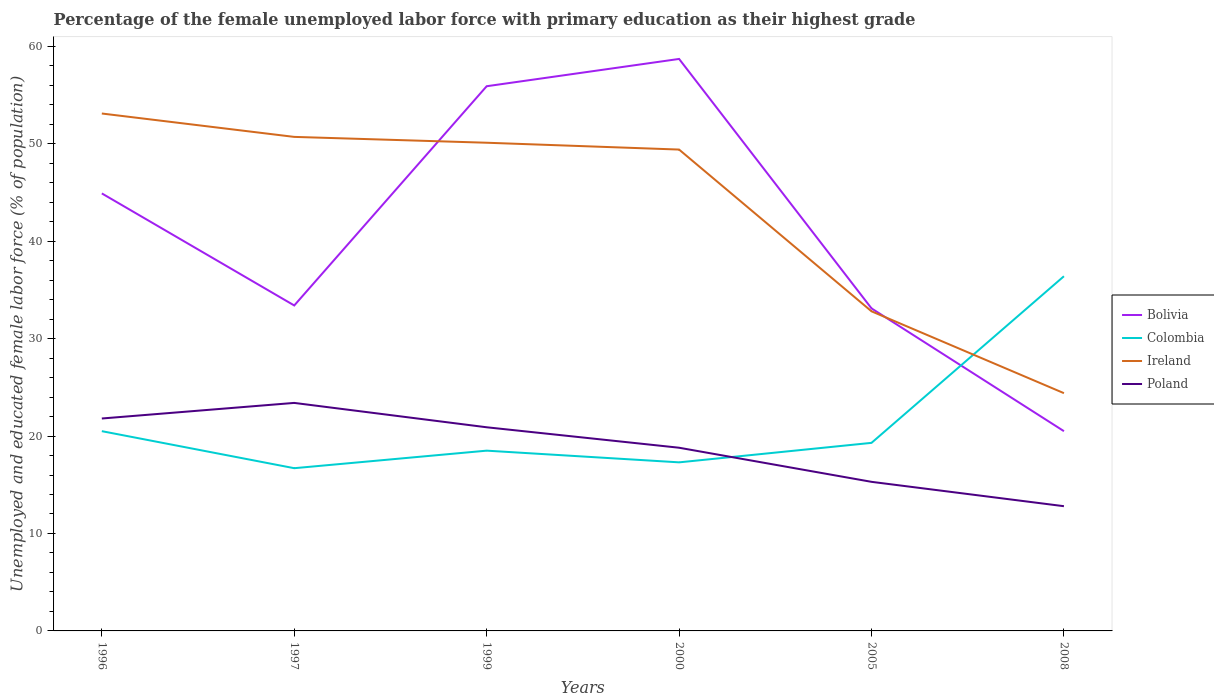Does the line corresponding to Ireland intersect with the line corresponding to Poland?
Your answer should be compact. No. Is the number of lines equal to the number of legend labels?
Provide a short and direct response. Yes. Across all years, what is the maximum percentage of the unemployed female labor force with primary education in Ireland?
Provide a succinct answer. 24.4. In which year was the percentage of the unemployed female labor force with primary education in Poland maximum?
Your answer should be very brief. 2008. What is the total percentage of the unemployed female labor force with primary education in Poland in the graph?
Keep it short and to the point. 6.5. What is the difference between the highest and the second highest percentage of the unemployed female labor force with primary education in Ireland?
Give a very brief answer. 28.7. What is the difference between the highest and the lowest percentage of the unemployed female labor force with primary education in Ireland?
Provide a short and direct response. 4. Is the percentage of the unemployed female labor force with primary education in Colombia strictly greater than the percentage of the unemployed female labor force with primary education in Bolivia over the years?
Your answer should be compact. No. How many years are there in the graph?
Your answer should be compact. 6. Are the values on the major ticks of Y-axis written in scientific E-notation?
Provide a short and direct response. No. Does the graph contain grids?
Offer a terse response. No. How many legend labels are there?
Provide a short and direct response. 4. How are the legend labels stacked?
Offer a terse response. Vertical. What is the title of the graph?
Provide a succinct answer. Percentage of the female unemployed labor force with primary education as their highest grade. Does "Lesotho" appear as one of the legend labels in the graph?
Provide a succinct answer. No. What is the label or title of the Y-axis?
Offer a very short reply. Unemployed and educated female labor force (% of population). What is the Unemployed and educated female labor force (% of population) of Bolivia in 1996?
Offer a terse response. 44.9. What is the Unemployed and educated female labor force (% of population) of Ireland in 1996?
Keep it short and to the point. 53.1. What is the Unemployed and educated female labor force (% of population) of Poland in 1996?
Your response must be concise. 21.8. What is the Unemployed and educated female labor force (% of population) in Bolivia in 1997?
Provide a short and direct response. 33.4. What is the Unemployed and educated female labor force (% of population) in Colombia in 1997?
Provide a succinct answer. 16.7. What is the Unemployed and educated female labor force (% of population) of Ireland in 1997?
Give a very brief answer. 50.7. What is the Unemployed and educated female labor force (% of population) of Poland in 1997?
Give a very brief answer. 23.4. What is the Unemployed and educated female labor force (% of population) in Bolivia in 1999?
Provide a short and direct response. 55.9. What is the Unemployed and educated female labor force (% of population) in Colombia in 1999?
Keep it short and to the point. 18.5. What is the Unemployed and educated female labor force (% of population) in Ireland in 1999?
Ensure brevity in your answer.  50.1. What is the Unemployed and educated female labor force (% of population) in Poland in 1999?
Provide a short and direct response. 20.9. What is the Unemployed and educated female labor force (% of population) in Bolivia in 2000?
Provide a succinct answer. 58.7. What is the Unemployed and educated female labor force (% of population) in Colombia in 2000?
Your answer should be compact. 17.3. What is the Unemployed and educated female labor force (% of population) in Ireland in 2000?
Offer a terse response. 49.4. What is the Unemployed and educated female labor force (% of population) of Poland in 2000?
Your response must be concise. 18.8. What is the Unemployed and educated female labor force (% of population) of Bolivia in 2005?
Offer a very short reply. 33.1. What is the Unemployed and educated female labor force (% of population) of Colombia in 2005?
Provide a short and direct response. 19.3. What is the Unemployed and educated female labor force (% of population) of Ireland in 2005?
Your answer should be very brief. 32.8. What is the Unemployed and educated female labor force (% of population) of Poland in 2005?
Your answer should be compact. 15.3. What is the Unemployed and educated female labor force (% of population) in Bolivia in 2008?
Offer a very short reply. 20.5. What is the Unemployed and educated female labor force (% of population) in Colombia in 2008?
Your answer should be very brief. 36.4. What is the Unemployed and educated female labor force (% of population) of Ireland in 2008?
Give a very brief answer. 24.4. What is the Unemployed and educated female labor force (% of population) in Poland in 2008?
Your answer should be compact. 12.8. Across all years, what is the maximum Unemployed and educated female labor force (% of population) in Bolivia?
Ensure brevity in your answer.  58.7. Across all years, what is the maximum Unemployed and educated female labor force (% of population) of Colombia?
Offer a very short reply. 36.4. Across all years, what is the maximum Unemployed and educated female labor force (% of population) in Ireland?
Make the answer very short. 53.1. Across all years, what is the maximum Unemployed and educated female labor force (% of population) of Poland?
Your answer should be very brief. 23.4. Across all years, what is the minimum Unemployed and educated female labor force (% of population) of Bolivia?
Offer a terse response. 20.5. Across all years, what is the minimum Unemployed and educated female labor force (% of population) in Colombia?
Provide a short and direct response. 16.7. Across all years, what is the minimum Unemployed and educated female labor force (% of population) of Ireland?
Your response must be concise. 24.4. Across all years, what is the minimum Unemployed and educated female labor force (% of population) in Poland?
Your answer should be very brief. 12.8. What is the total Unemployed and educated female labor force (% of population) in Bolivia in the graph?
Make the answer very short. 246.5. What is the total Unemployed and educated female labor force (% of population) in Colombia in the graph?
Ensure brevity in your answer.  128.7. What is the total Unemployed and educated female labor force (% of population) of Ireland in the graph?
Your answer should be very brief. 260.5. What is the total Unemployed and educated female labor force (% of population) in Poland in the graph?
Offer a very short reply. 113. What is the difference between the Unemployed and educated female labor force (% of population) of Colombia in 1996 and that in 1997?
Provide a short and direct response. 3.8. What is the difference between the Unemployed and educated female labor force (% of population) of Colombia in 1996 and that in 1999?
Provide a short and direct response. 2. What is the difference between the Unemployed and educated female labor force (% of population) of Ireland in 1996 and that in 1999?
Give a very brief answer. 3. What is the difference between the Unemployed and educated female labor force (% of population) of Poland in 1996 and that in 2000?
Make the answer very short. 3. What is the difference between the Unemployed and educated female labor force (% of population) of Bolivia in 1996 and that in 2005?
Provide a short and direct response. 11.8. What is the difference between the Unemployed and educated female labor force (% of population) of Ireland in 1996 and that in 2005?
Make the answer very short. 20.3. What is the difference between the Unemployed and educated female labor force (% of population) of Bolivia in 1996 and that in 2008?
Make the answer very short. 24.4. What is the difference between the Unemployed and educated female labor force (% of population) of Colombia in 1996 and that in 2008?
Provide a short and direct response. -15.9. What is the difference between the Unemployed and educated female labor force (% of population) of Ireland in 1996 and that in 2008?
Keep it short and to the point. 28.7. What is the difference between the Unemployed and educated female labor force (% of population) of Poland in 1996 and that in 2008?
Your response must be concise. 9. What is the difference between the Unemployed and educated female labor force (% of population) in Bolivia in 1997 and that in 1999?
Offer a very short reply. -22.5. What is the difference between the Unemployed and educated female labor force (% of population) in Poland in 1997 and that in 1999?
Your response must be concise. 2.5. What is the difference between the Unemployed and educated female labor force (% of population) of Bolivia in 1997 and that in 2000?
Offer a very short reply. -25.3. What is the difference between the Unemployed and educated female labor force (% of population) in Ireland in 1997 and that in 2000?
Offer a terse response. 1.3. What is the difference between the Unemployed and educated female labor force (% of population) of Bolivia in 1997 and that in 2005?
Keep it short and to the point. 0.3. What is the difference between the Unemployed and educated female labor force (% of population) in Colombia in 1997 and that in 2005?
Make the answer very short. -2.6. What is the difference between the Unemployed and educated female labor force (% of population) of Poland in 1997 and that in 2005?
Your answer should be very brief. 8.1. What is the difference between the Unemployed and educated female labor force (% of population) in Bolivia in 1997 and that in 2008?
Offer a very short reply. 12.9. What is the difference between the Unemployed and educated female labor force (% of population) of Colombia in 1997 and that in 2008?
Provide a succinct answer. -19.7. What is the difference between the Unemployed and educated female labor force (% of population) in Ireland in 1997 and that in 2008?
Your answer should be very brief. 26.3. What is the difference between the Unemployed and educated female labor force (% of population) in Poland in 1997 and that in 2008?
Your answer should be very brief. 10.6. What is the difference between the Unemployed and educated female labor force (% of population) of Bolivia in 1999 and that in 2000?
Your answer should be very brief. -2.8. What is the difference between the Unemployed and educated female labor force (% of population) of Colombia in 1999 and that in 2000?
Ensure brevity in your answer.  1.2. What is the difference between the Unemployed and educated female labor force (% of population) of Ireland in 1999 and that in 2000?
Make the answer very short. 0.7. What is the difference between the Unemployed and educated female labor force (% of population) of Bolivia in 1999 and that in 2005?
Make the answer very short. 22.8. What is the difference between the Unemployed and educated female labor force (% of population) in Colombia in 1999 and that in 2005?
Ensure brevity in your answer.  -0.8. What is the difference between the Unemployed and educated female labor force (% of population) of Ireland in 1999 and that in 2005?
Provide a short and direct response. 17.3. What is the difference between the Unemployed and educated female labor force (% of population) of Bolivia in 1999 and that in 2008?
Make the answer very short. 35.4. What is the difference between the Unemployed and educated female labor force (% of population) in Colombia in 1999 and that in 2008?
Provide a short and direct response. -17.9. What is the difference between the Unemployed and educated female labor force (% of population) of Ireland in 1999 and that in 2008?
Give a very brief answer. 25.7. What is the difference between the Unemployed and educated female labor force (% of population) in Bolivia in 2000 and that in 2005?
Provide a succinct answer. 25.6. What is the difference between the Unemployed and educated female labor force (% of population) in Ireland in 2000 and that in 2005?
Provide a succinct answer. 16.6. What is the difference between the Unemployed and educated female labor force (% of population) in Poland in 2000 and that in 2005?
Your response must be concise. 3.5. What is the difference between the Unemployed and educated female labor force (% of population) in Bolivia in 2000 and that in 2008?
Provide a succinct answer. 38.2. What is the difference between the Unemployed and educated female labor force (% of population) of Colombia in 2000 and that in 2008?
Offer a very short reply. -19.1. What is the difference between the Unemployed and educated female labor force (% of population) of Poland in 2000 and that in 2008?
Keep it short and to the point. 6. What is the difference between the Unemployed and educated female labor force (% of population) of Colombia in 2005 and that in 2008?
Offer a terse response. -17.1. What is the difference between the Unemployed and educated female labor force (% of population) of Bolivia in 1996 and the Unemployed and educated female labor force (% of population) of Colombia in 1997?
Provide a short and direct response. 28.2. What is the difference between the Unemployed and educated female labor force (% of population) in Bolivia in 1996 and the Unemployed and educated female labor force (% of population) in Ireland in 1997?
Provide a short and direct response. -5.8. What is the difference between the Unemployed and educated female labor force (% of population) in Colombia in 1996 and the Unemployed and educated female labor force (% of population) in Ireland in 1997?
Offer a terse response. -30.2. What is the difference between the Unemployed and educated female labor force (% of population) in Ireland in 1996 and the Unemployed and educated female labor force (% of population) in Poland in 1997?
Your answer should be very brief. 29.7. What is the difference between the Unemployed and educated female labor force (% of population) in Bolivia in 1996 and the Unemployed and educated female labor force (% of population) in Colombia in 1999?
Provide a short and direct response. 26.4. What is the difference between the Unemployed and educated female labor force (% of population) in Bolivia in 1996 and the Unemployed and educated female labor force (% of population) in Poland in 1999?
Keep it short and to the point. 24. What is the difference between the Unemployed and educated female labor force (% of population) of Colombia in 1996 and the Unemployed and educated female labor force (% of population) of Ireland in 1999?
Offer a very short reply. -29.6. What is the difference between the Unemployed and educated female labor force (% of population) of Ireland in 1996 and the Unemployed and educated female labor force (% of population) of Poland in 1999?
Your answer should be very brief. 32.2. What is the difference between the Unemployed and educated female labor force (% of population) in Bolivia in 1996 and the Unemployed and educated female labor force (% of population) in Colombia in 2000?
Offer a terse response. 27.6. What is the difference between the Unemployed and educated female labor force (% of population) in Bolivia in 1996 and the Unemployed and educated female labor force (% of population) in Poland in 2000?
Ensure brevity in your answer.  26.1. What is the difference between the Unemployed and educated female labor force (% of population) in Colombia in 1996 and the Unemployed and educated female labor force (% of population) in Ireland in 2000?
Ensure brevity in your answer.  -28.9. What is the difference between the Unemployed and educated female labor force (% of population) of Colombia in 1996 and the Unemployed and educated female labor force (% of population) of Poland in 2000?
Provide a succinct answer. 1.7. What is the difference between the Unemployed and educated female labor force (% of population) in Ireland in 1996 and the Unemployed and educated female labor force (% of population) in Poland in 2000?
Offer a terse response. 34.3. What is the difference between the Unemployed and educated female labor force (% of population) of Bolivia in 1996 and the Unemployed and educated female labor force (% of population) of Colombia in 2005?
Offer a very short reply. 25.6. What is the difference between the Unemployed and educated female labor force (% of population) in Bolivia in 1996 and the Unemployed and educated female labor force (% of population) in Ireland in 2005?
Your response must be concise. 12.1. What is the difference between the Unemployed and educated female labor force (% of population) of Bolivia in 1996 and the Unemployed and educated female labor force (% of population) of Poland in 2005?
Your answer should be compact. 29.6. What is the difference between the Unemployed and educated female labor force (% of population) in Ireland in 1996 and the Unemployed and educated female labor force (% of population) in Poland in 2005?
Your answer should be compact. 37.8. What is the difference between the Unemployed and educated female labor force (% of population) in Bolivia in 1996 and the Unemployed and educated female labor force (% of population) in Colombia in 2008?
Provide a short and direct response. 8.5. What is the difference between the Unemployed and educated female labor force (% of population) in Bolivia in 1996 and the Unemployed and educated female labor force (% of population) in Poland in 2008?
Ensure brevity in your answer.  32.1. What is the difference between the Unemployed and educated female labor force (% of population) of Colombia in 1996 and the Unemployed and educated female labor force (% of population) of Ireland in 2008?
Offer a terse response. -3.9. What is the difference between the Unemployed and educated female labor force (% of population) in Colombia in 1996 and the Unemployed and educated female labor force (% of population) in Poland in 2008?
Give a very brief answer. 7.7. What is the difference between the Unemployed and educated female labor force (% of population) of Ireland in 1996 and the Unemployed and educated female labor force (% of population) of Poland in 2008?
Keep it short and to the point. 40.3. What is the difference between the Unemployed and educated female labor force (% of population) of Bolivia in 1997 and the Unemployed and educated female labor force (% of population) of Ireland in 1999?
Ensure brevity in your answer.  -16.7. What is the difference between the Unemployed and educated female labor force (% of population) in Bolivia in 1997 and the Unemployed and educated female labor force (% of population) in Poland in 1999?
Your answer should be compact. 12.5. What is the difference between the Unemployed and educated female labor force (% of population) in Colombia in 1997 and the Unemployed and educated female labor force (% of population) in Ireland in 1999?
Ensure brevity in your answer.  -33.4. What is the difference between the Unemployed and educated female labor force (% of population) in Colombia in 1997 and the Unemployed and educated female labor force (% of population) in Poland in 1999?
Provide a succinct answer. -4.2. What is the difference between the Unemployed and educated female labor force (% of population) of Ireland in 1997 and the Unemployed and educated female labor force (% of population) of Poland in 1999?
Your answer should be compact. 29.8. What is the difference between the Unemployed and educated female labor force (% of population) in Bolivia in 1997 and the Unemployed and educated female labor force (% of population) in Colombia in 2000?
Make the answer very short. 16.1. What is the difference between the Unemployed and educated female labor force (% of population) of Bolivia in 1997 and the Unemployed and educated female labor force (% of population) of Ireland in 2000?
Your answer should be very brief. -16. What is the difference between the Unemployed and educated female labor force (% of population) in Bolivia in 1997 and the Unemployed and educated female labor force (% of population) in Poland in 2000?
Make the answer very short. 14.6. What is the difference between the Unemployed and educated female labor force (% of population) of Colombia in 1997 and the Unemployed and educated female labor force (% of population) of Ireland in 2000?
Provide a short and direct response. -32.7. What is the difference between the Unemployed and educated female labor force (% of population) in Colombia in 1997 and the Unemployed and educated female labor force (% of population) in Poland in 2000?
Ensure brevity in your answer.  -2.1. What is the difference between the Unemployed and educated female labor force (% of population) in Ireland in 1997 and the Unemployed and educated female labor force (% of population) in Poland in 2000?
Your answer should be very brief. 31.9. What is the difference between the Unemployed and educated female labor force (% of population) of Bolivia in 1997 and the Unemployed and educated female labor force (% of population) of Colombia in 2005?
Offer a terse response. 14.1. What is the difference between the Unemployed and educated female labor force (% of population) of Colombia in 1997 and the Unemployed and educated female labor force (% of population) of Ireland in 2005?
Ensure brevity in your answer.  -16.1. What is the difference between the Unemployed and educated female labor force (% of population) in Colombia in 1997 and the Unemployed and educated female labor force (% of population) in Poland in 2005?
Your response must be concise. 1.4. What is the difference between the Unemployed and educated female labor force (% of population) of Ireland in 1997 and the Unemployed and educated female labor force (% of population) of Poland in 2005?
Your answer should be very brief. 35.4. What is the difference between the Unemployed and educated female labor force (% of population) of Bolivia in 1997 and the Unemployed and educated female labor force (% of population) of Poland in 2008?
Your answer should be very brief. 20.6. What is the difference between the Unemployed and educated female labor force (% of population) in Colombia in 1997 and the Unemployed and educated female labor force (% of population) in Poland in 2008?
Keep it short and to the point. 3.9. What is the difference between the Unemployed and educated female labor force (% of population) in Ireland in 1997 and the Unemployed and educated female labor force (% of population) in Poland in 2008?
Provide a short and direct response. 37.9. What is the difference between the Unemployed and educated female labor force (% of population) in Bolivia in 1999 and the Unemployed and educated female labor force (% of population) in Colombia in 2000?
Keep it short and to the point. 38.6. What is the difference between the Unemployed and educated female labor force (% of population) of Bolivia in 1999 and the Unemployed and educated female labor force (% of population) of Ireland in 2000?
Make the answer very short. 6.5. What is the difference between the Unemployed and educated female labor force (% of population) of Bolivia in 1999 and the Unemployed and educated female labor force (% of population) of Poland in 2000?
Your response must be concise. 37.1. What is the difference between the Unemployed and educated female labor force (% of population) in Colombia in 1999 and the Unemployed and educated female labor force (% of population) in Ireland in 2000?
Provide a short and direct response. -30.9. What is the difference between the Unemployed and educated female labor force (% of population) of Colombia in 1999 and the Unemployed and educated female labor force (% of population) of Poland in 2000?
Give a very brief answer. -0.3. What is the difference between the Unemployed and educated female labor force (% of population) of Ireland in 1999 and the Unemployed and educated female labor force (% of population) of Poland in 2000?
Make the answer very short. 31.3. What is the difference between the Unemployed and educated female labor force (% of population) in Bolivia in 1999 and the Unemployed and educated female labor force (% of population) in Colombia in 2005?
Your answer should be compact. 36.6. What is the difference between the Unemployed and educated female labor force (% of population) of Bolivia in 1999 and the Unemployed and educated female labor force (% of population) of Ireland in 2005?
Offer a very short reply. 23.1. What is the difference between the Unemployed and educated female labor force (% of population) of Bolivia in 1999 and the Unemployed and educated female labor force (% of population) of Poland in 2005?
Make the answer very short. 40.6. What is the difference between the Unemployed and educated female labor force (% of population) of Colombia in 1999 and the Unemployed and educated female labor force (% of population) of Ireland in 2005?
Offer a very short reply. -14.3. What is the difference between the Unemployed and educated female labor force (% of population) of Ireland in 1999 and the Unemployed and educated female labor force (% of population) of Poland in 2005?
Offer a terse response. 34.8. What is the difference between the Unemployed and educated female labor force (% of population) in Bolivia in 1999 and the Unemployed and educated female labor force (% of population) in Colombia in 2008?
Offer a terse response. 19.5. What is the difference between the Unemployed and educated female labor force (% of population) of Bolivia in 1999 and the Unemployed and educated female labor force (% of population) of Ireland in 2008?
Give a very brief answer. 31.5. What is the difference between the Unemployed and educated female labor force (% of population) of Bolivia in 1999 and the Unemployed and educated female labor force (% of population) of Poland in 2008?
Provide a succinct answer. 43.1. What is the difference between the Unemployed and educated female labor force (% of population) of Colombia in 1999 and the Unemployed and educated female labor force (% of population) of Poland in 2008?
Provide a short and direct response. 5.7. What is the difference between the Unemployed and educated female labor force (% of population) of Ireland in 1999 and the Unemployed and educated female labor force (% of population) of Poland in 2008?
Provide a short and direct response. 37.3. What is the difference between the Unemployed and educated female labor force (% of population) of Bolivia in 2000 and the Unemployed and educated female labor force (% of population) of Colombia in 2005?
Give a very brief answer. 39.4. What is the difference between the Unemployed and educated female labor force (% of population) of Bolivia in 2000 and the Unemployed and educated female labor force (% of population) of Ireland in 2005?
Ensure brevity in your answer.  25.9. What is the difference between the Unemployed and educated female labor force (% of population) of Bolivia in 2000 and the Unemployed and educated female labor force (% of population) of Poland in 2005?
Provide a succinct answer. 43.4. What is the difference between the Unemployed and educated female labor force (% of population) of Colombia in 2000 and the Unemployed and educated female labor force (% of population) of Ireland in 2005?
Ensure brevity in your answer.  -15.5. What is the difference between the Unemployed and educated female labor force (% of population) of Ireland in 2000 and the Unemployed and educated female labor force (% of population) of Poland in 2005?
Provide a short and direct response. 34.1. What is the difference between the Unemployed and educated female labor force (% of population) of Bolivia in 2000 and the Unemployed and educated female labor force (% of population) of Colombia in 2008?
Your response must be concise. 22.3. What is the difference between the Unemployed and educated female labor force (% of population) in Bolivia in 2000 and the Unemployed and educated female labor force (% of population) in Ireland in 2008?
Provide a short and direct response. 34.3. What is the difference between the Unemployed and educated female labor force (% of population) of Bolivia in 2000 and the Unemployed and educated female labor force (% of population) of Poland in 2008?
Provide a short and direct response. 45.9. What is the difference between the Unemployed and educated female labor force (% of population) of Colombia in 2000 and the Unemployed and educated female labor force (% of population) of Ireland in 2008?
Offer a terse response. -7.1. What is the difference between the Unemployed and educated female labor force (% of population) in Colombia in 2000 and the Unemployed and educated female labor force (% of population) in Poland in 2008?
Give a very brief answer. 4.5. What is the difference between the Unemployed and educated female labor force (% of population) of Ireland in 2000 and the Unemployed and educated female labor force (% of population) of Poland in 2008?
Make the answer very short. 36.6. What is the difference between the Unemployed and educated female labor force (% of population) of Bolivia in 2005 and the Unemployed and educated female labor force (% of population) of Colombia in 2008?
Give a very brief answer. -3.3. What is the difference between the Unemployed and educated female labor force (% of population) in Bolivia in 2005 and the Unemployed and educated female labor force (% of population) in Poland in 2008?
Make the answer very short. 20.3. What is the difference between the Unemployed and educated female labor force (% of population) in Colombia in 2005 and the Unemployed and educated female labor force (% of population) in Ireland in 2008?
Your answer should be compact. -5.1. What is the average Unemployed and educated female labor force (% of population) of Bolivia per year?
Provide a succinct answer. 41.08. What is the average Unemployed and educated female labor force (% of population) of Colombia per year?
Ensure brevity in your answer.  21.45. What is the average Unemployed and educated female labor force (% of population) of Ireland per year?
Ensure brevity in your answer.  43.42. What is the average Unemployed and educated female labor force (% of population) in Poland per year?
Your answer should be very brief. 18.83. In the year 1996, what is the difference between the Unemployed and educated female labor force (% of population) of Bolivia and Unemployed and educated female labor force (% of population) of Colombia?
Provide a short and direct response. 24.4. In the year 1996, what is the difference between the Unemployed and educated female labor force (% of population) in Bolivia and Unemployed and educated female labor force (% of population) in Poland?
Your response must be concise. 23.1. In the year 1996, what is the difference between the Unemployed and educated female labor force (% of population) in Colombia and Unemployed and educated female labor force (% of population) in Ireland?
Ensure brevity in your answer.  -32.6. In the year 1996, what is the difference between the Unemployed and educated female labor force (% of population) of Ireland and Unemployed and educated female labor force (% of population) of Poland?
Your response must be concise. 31.3. In the year 1997, what is the difference between the Unemployed and educated female labor force (% of population) of Bolivia and Unemployed and educated female labor force (% of population) of Ireland?
Keep it short and to the point. -17.3. In the year 1997, what is the difference between the Unemployed and educated female labor force (% of population) in Bolivia and Unemployed and educated female labor force (% of population) in Poland?
Your answer should be very brief. 10. In the year 1997, what is the difference between the Unemployed and educated female labor force (% of population) of Colombia and Unemployed and educated female labor force (% of population) of Ireland?
Your response must be concise. -34. In the year 1997, what is the difference between the Unemployed and educated female labor force (% of population) in Colombia and Unemployed and educated female labor force (% of population) in Poland?
Provide a short and direct response. -6.7. In the year 1997, what is the difference between the Unemployed and educated female labor force (% of population) in Ireland and Unemployed and educated female labor force (% of population) in Poland?
Your answer should be compact. 27.3. In the year 1999, what is the difference between the Unemployed and educated female labor force (% of population) in Bolivia and Unemployed and educated female labor force (% of population) in Colombia?
Provide a short and direct response. 37.4. In the year 1999, what is the difference between the Unemployed and educated female labor force (% of population) of Colombia and Unemployed and educated female labor force (% of population) of Ireland?
Offer a terse response. -31.6. In the year 1999, what is the difference between the Unemployed and educated female labor force (% of population) in Colombia and Unemployed and educated female labor force (% of population) in Poland?
Your response must be concise. -2.4. In the year 1999, what is the difference between the Unemployed and educated female labor force (% of population) in Ireland and Unemployed and educated female labor force (% of population) in Poland?
Offer a terse response. 29.2. In the year 2000, what is the difference between the Unemployed and educated female labor force (% of population) in Bolivia and Unemployed and educated female labor force (% of population) in Colombia?
Your answer should be very brief. 41.4. In the year 2000, what is the difference between the Unemployed and educated female labor force (% of population) in Bolivia and Unemployed and educated female labor force (% of population) in Ireland?
Ensure brevity in your answer.  9.3. In the year 2000, what is the difference between the Unemployed and educated female labor force (% of population) of Bolivia and Unemployed and educated female labor force (% of population) of Poland?
Your answer should be very brief. 39.9. In the year 2000, what is the difference between the Unemployed and educated female labor force (% of population) of Colombia and Unemployed and educated female labor force (% of population) of Ireland?
Offer a terse response. -32.1. In the year 2000, what is the difference between the Unemployed and educated female labor force (% of population) of Colombia and Unemployed and educated female labor force (% of population) of Poland?
Offer a very short reply. -1.5. In the year 2000, what is the difference between the Unemployed and educated female labor force (% of population) of Ireland and Unemployed and educated female labor force (% of population) of Poland?
Offer a very short reply. 30.6. In the year 2005, what is the difference between the Unemployed and educated female labor force (% of population) in Bolivia and Unemployed and educated female labor force (% of population) in Ireland?
Make the answer very short. 0.3. In the year 2005, what is the difference between the Unemployed and educated female labor force (% of population) of Colombia and Unemployed and educated female labor force (% of population) of Ireland?
Your answer should be compact. -13.5. In the year 2005, what is the difference between the Unemployed and educated female labor force (% of population) in Colombia and Unemployed and educated female labor force (% of population) in Poland?
Your answer should be very brief. 4. In the year 2005, what is the difference between the Unemployed and educated female labor force (% of population) in Ireland and Unemployed and educated female labor force (% of population) in Poland?
Keep it short and to the point. 17.5. In the year 2008, what is the difference between the Unemployed and educated female labor force (% of population) of Bolivia and Unemployed and educated female labor force (% of population) of Colombia?
Your answer should be compact. -15.9. In the year 2008, what is the difference between the Unemployed and educated female labor force (% of population) in Bolivia and Unemployed and educated female labor force (% of population) in Poland?
Your answer should be compact. 7.7. In the year 2008, what is the difference between the Unemployed and educated female labor force (% of population) in Colombia and Unemployed and educated female labor force (% of population) in Poland?
Your response must be concise. 23.6. What is the ratio of the Unemployed and educated female labor force (% of population) in Bolivia in 1996 to that in 1997?
Your answer should be very brief. 1.34. What is the ratio of the Unemployed and educated female labor force (% of population) of Colombia in 1996 to that in 1997?
Offer a very short reply. 1.23. What is the ratio of the Unemployed and educated female labor force (% of population) in Ireland in 1996 to that in 1997?
Make the answer very short. 1.05. What is the ratio of the Unemployed and educated female labor force (% of population) in Poland in 1996 to that in 1997?
Your answer should be very brief. 0.93. What is the ratio of the Unemployed and educated female labor force (% of population) in Bolivia in 1996 to that in 1999?
Offer a very short reply. 0.8. What is the ratio of the Unemployed and educated female labor force (% of population) in Colombia in 1996 to that in 1999?
Your response must be concise. 1.11. What is the ratio of the Unemployed and educated female labor force (% of population) of Ireland in 1996 to that in 1999?
Make the answer very short. 1.06. What is the ratio of the Unemployed and educated female labor force (% of population) in Poland in 1996 to that in 1999?
Ensure brevity in your answer.  1.04. What is the ratio of the Unemployed and educated female labor force (% of population) in Bolivia in 1996 to that in 2000?
Your response must be concise. 0.76. What is the ratio of the Unemployed and educated female labor force (% of population) in Colombia in 1996 to that in 2000?
Your answer should be compact. 1.19. What is the ratio of the Unemployed and educated female labor force (% of population) in Ireland in 1996 to that in 2000?
Offer a very short reply. 1.07. What is the ratio of the Unemployed and educated female labor force (% of population) in Poland in 1996 to that in 2000?
Your answer should be compact. 1.16. What is the ratio of the Unemployed and educated female labor force (% of population) in Bolivia in 1996 to that in 2005?
Your answer should be compact. 1.36. What is the ratio of the Unemployed and educated female labor force (% of population) of Colombia in 1996 to that in 2005?
Your answer should be very brief. 1.06. What is the ratio of the Unemployed and educated female labor force (% of population) in Ireland in 1996 to that in 2005?
Offer a very short reply. 1.62. What is the ratio of the Unemployed and educated female labor force (% of population) of Poland in 1996 to that in 2005?
Your answer should be compact. 1.42. What is the ratio of the Unemployed and educated female labor force (% of population) in Bolivia in 1996 to that in 2008?
Your answer should be compact. 2.19. What is the ratio of the Unemployed and educated female labor force (% of population) of Colombia in 1996 to that in 2008?
Provide a succinct answer. 0.56. What is the ratio of the Unemployed and educated female labor force (% of population) of Ireland in 1996 to that in 2008?
Offer a terse response. 2.18. What is the ratio of the Unemployed and educated female labor force (% of population) in Poland in 1996 to that in 2008?
Give a very brief answer. 1.7. What is the ratio of the Unemployed and educated female labor force (% of population) in Bolivia in 1997 to that in 1999?
Offer a terse response. 0.6. What is the ratio of the Unemployed and educated female labor force (% of population) in Colombia in 1997 to that in 1999?
Provide a succinct answer. 0.9. What is the ratio of the Unemployed and educated female labor force (% of population) in Ireland in 1997 to that in 1999?
Your answer should be very brief. 1.01. What is the ratio of the Unemployed and educated female labor force (% of population) in Poland in 1997 to that in 1999?
Provide a succinct answer. 1.12. What is the ratio of the Unemployed and educated female labor force (% of population) of Bolivia in 1997 to that in 2000?
Give a very brief answer. 0.57. What is the ratio of the Unemployed and educated female labor force (% of population) of Colombia in 1997 to that in 2000?
Offer a terse response. 0.97. What is the ratio of the Unemployed and educated female labor force (% of population) of Ireland in 1997 to that in 2000?
Give a very brief answer. 1.03. What is the ratio of the Unemployed and educated female labor force (% of population) of Poland in 1997 to that in 2000?
Ensure brevity in your answer.  1.24. What is the ratio of the Unemployed and educated female labor force (% of population) in Bolivia in 1997 to that in 2005?
Your answer should be compact. 1.01. What is the ratio of the Unemployed and educated female labor force (% of population) of Colombia in 1997 to that in 2005?
Offer a terse response. 0.87. What is the ratio of the Unemployed and educated female labor force (% of population) of Ireland in 1997 to that in 2005?
Your answer should be compact. 1.55. What is the ratio of the Unemployed and educated female labor force (% of population) of Poland in 1997 to that in 2005?
Your answer should be very brief. 1.53. What is the ratio of the Unemployed and educated female labor force (% of population) in Bolivia in 1997 to that in 2008?
Your answer should be compact. 1.63. What is the ratio of the Unemployed and educated female labor force (% of population) of Colombia in 1997 to that in 2008?
Your response must be concise. 0.46. What is the ratio of the Unemployed and educated female labor force (% of population) in Ireland in 1997 to that in 2008?
Provide a short and direct response. 2.08. What is the ratio of the Unemployed and educated female labor force (% of population) in Poland in 1997 to that in 2008?
Offer a very short reply. 1.83. What is the ratio of the Unemployed and educated female labor force (% of population) in Bolivia in 1999 to that in 2000?
Provide a short and direct response. 0.95. What is the ratio of the Unemployed and educated female labor force (% of population) in Colombia in 1999 to that in 2000?
Keep it short and to the point. 1.07. What is the ratio of the Unemployed and educated female labor force (% of population) of Ireland in 1999 to that in 2000?
Offer a terse response. 1.01. What is the ratio of the Unemployed and educated female labor force (% of population) in Poland in 1999 to that in 2000?
Your answer should be very brief. 1.11. What is the ratio of the Unemployed and educated female labor force (% of population) of Bolivia in 1999 to that in 2005?
Provide a succinct answer. 1.69. What is the ratio of the Unemployed and educated female labor force (% of population) of Colombia in 1999 to that in 2005?
Your answer should be compact. 0.96. What is the ratio of the Unemployed and educated female labor force (% of population) in Ireland in 1999 to that in 2005?
Provide a succinct answer. 1.53. What is the ratio of the Unemployed and educated female labor force (% of population) of Poland in 1999 to that in 2005?
Offer a terse response. 1.37. What is the ratio of the Unemployed and educated female labor force (% of population) of Bolivia in 1999 to that in 2008?
Offer a terse response. 2.73. What is the ratio of the Unemployed and educated female labor force (% of population) of Colombia in 1999 to that in 2008?
Ensure brevity in your answer.  0.51. What is the ratio of the Unemployed and educated female labor force (% of population) in Ireland in 1999 to that in 2008?
Your response must be concise. 2.05. What is the ratio of the Unemployed and educated female labor force (% of population) of Poland in 1999 to that in 2008?
Make the answer very short. 1.63. What is the ratio of the Unemployed and educated female labor force (% of population) of Bolivia in 2000 to that in 2005?
Provide a succinct answer. 1.77. What is the ratio of the Unemployed and educated female labor force (% of population) of Colombia in 2000 to that in 2005?
Provide a succinct answer. 0.9. What is the ratio of the Unemployed and educated female labor force (% of population) in Ireland in 2000 to that in 2005?
Offer a terse response. 1.51. What is the ratio of the Unemployed and educated female labor force (% of population) of Poland in 2000 to that in 2005?
Provide a short and direct response. 1.23. What is the ratio of the Unemployed and educated female labor force (% of population) of Bolivia in 2000 to that in 2008?
Provide a short and direct response. 2.86. What is the ratio of the Unemployed and educated female labor force (% of population) of Colombia in 2000 to that in 2008?
Make the answer very short. 0.48. What is the ratio of the Unemployed and educated female labor force (% of population) of Ireland in 2000 to that in 2008?
Give a very brief answer. 2.02. What is the ratio of the Unemployed and educated female labor force (% of population) in Poland in 2000 to that in 2008?
Make the answer very short. 1.47. What is the ratio of the Unemployed and educated female labor force (% of population) in Bolivia in 2005 to that in 2008?
Offer a terse response. 1.61. What is the ratio of the Unemployed and educated female labor force (% of population) of Colombia in 2005 to that in 2008?
Your answer should be compact. 0.53. What is the ratio of the Unemployed and educated female labor force (% of population) in Ireland in 2005 to that in 2008?
Provide a succinct answer. 1.34. What is the ratio of the Unemployed and educated female labor force (% of population) in Poland in 2005 to that in 2008?
Make the answer very short. 1.2. What is the difference between the highest and the second highest Unemployed and educated female labor force (% of population) in Bolivia?
Offer a terse response. 2.8. What is the difference between the highest and the second highest Unemployed and educated female labor force (% of population) of Ireland?
Your answer should be very brief. 2.4. What is the difference between the highest and the second highest Unemployed and educated female labor force (% of population) of Poland?
Offer a terse response. 1.6. What is the difference between the highest and the lowest Unemployed and educated female labor force (% of population) in Bolivia?
Your response must be concise. 38.2. What is the difference between the highest and the lowest Unemployed and educated female labor force (% of population) in Colombia?
Keep it short and to the point. 19.7. What is the difference between the highest and the lowest Unemployed and educated female labor force (% of population) of Ireland?
Keep it short and to the point. 28.7. What is the difference between the highest and the lowest Unemployed and educated female labor force (% of population) of Poland?
Keep it short and to the point. 10.6. 